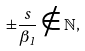<formula> <loc_0><loc_0><loc_500><loc_500>\pm \frac { s } { \beta _ { 1 } } \notin \mathbb { N } ,</formula> 